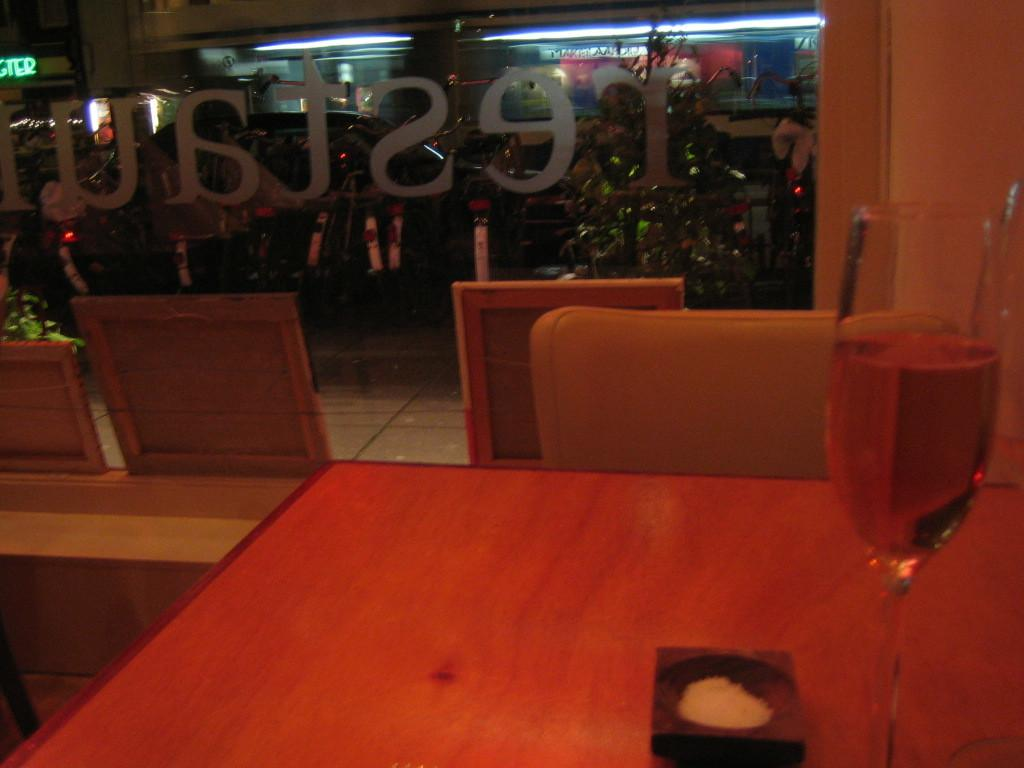What piece of furniture is present in the image? There is a table in the image. What is placed on the table? A wine glass is placed on the table. What else can be found on the table? There are objects on the table. What type of seating is visible in the image? There is a chair in the image. What can be seen in the background of the image? A car is parked in the background. Is there any greenery present in the image? Yes, there is a small plant in the image. How does the dog grip the wine glass in the image? There is no dog present in the image, and therefore no interaction with the wine glass can be observed. 